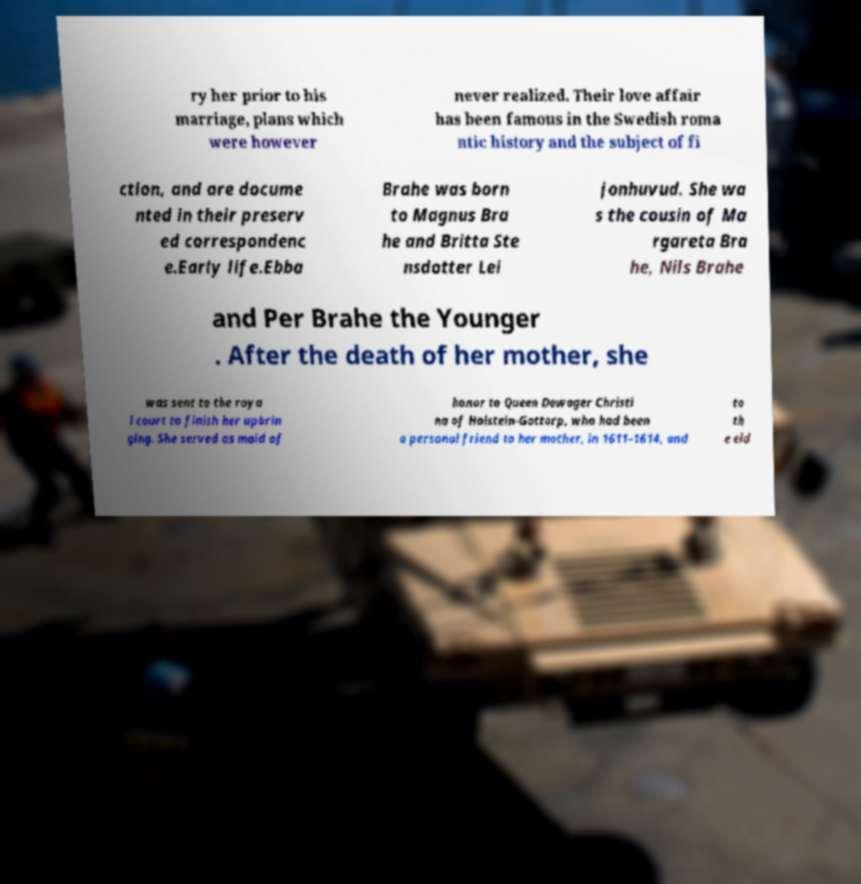There's text embedded in this image that I need extracted. Can you transcribe it verbatim? ry her prior to his marriage, plans which were however never realized. Their love affair has been famous in the Swedish roma ntic history and the subject of fi ction, and are docume nted in their preserv ed correspondenc e.Early life.Ebba Brahe was born to Magnus Bra he and Britta Ste nsdotter Lei jonhuvud. She wa s the cousin of Ma rgareta Bra he, Nils Brahe and Per Brahe the Younger . After the death of her mother, she was sent to the roya l court to finish her upbrin ging. She served as maid of honor to Queen Dowager Christi na of Holstein-Gottorp, who had been a personal friend to her mother, in 1611–1614, and to th e eld 